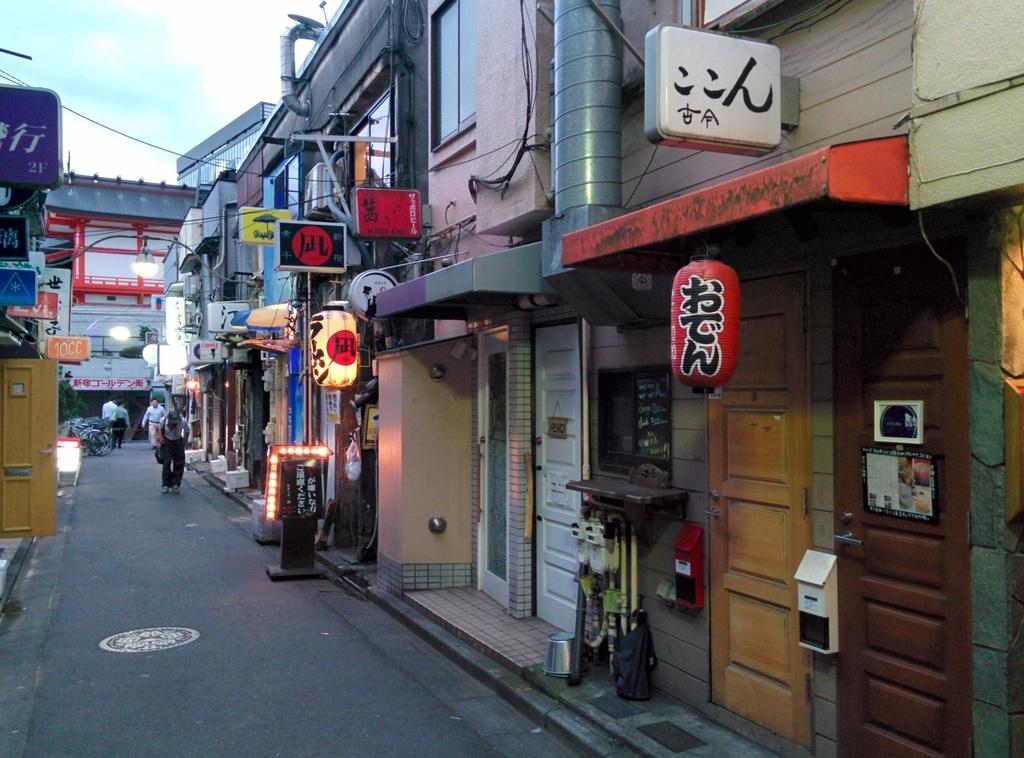What are the people in the image doing? There is a group of people standing on the road in the image. What can be seen in the background of the image? The sky is visible in the background of the image. What type of structures are present in the image? There are buildings in the image. What other objects can be seen in the image? There are boards, lights, and cables in the image. What type of poison is being used by the people in the image? There is no indication of poison or any such activity in the image; the people are simply standing on the road. 